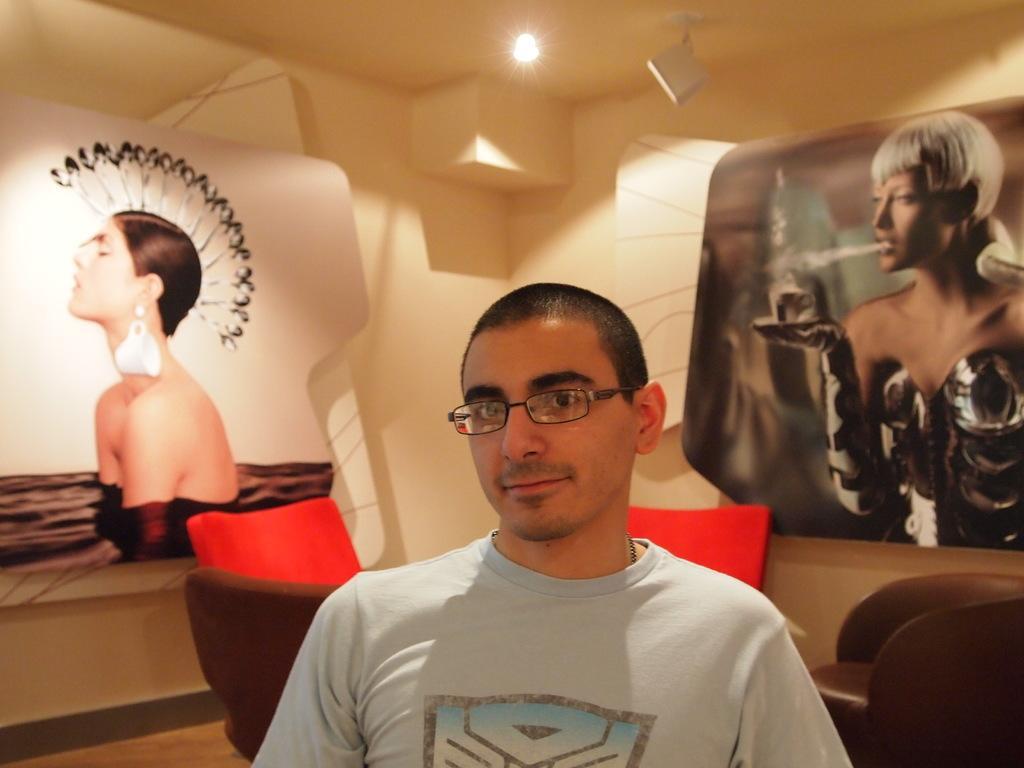Describe this image in one or two sentences. In this image I can see the person with t-shirt and specs. In the background I can see the chairs. I can also see two people in the boards. I can see the light in the top. 